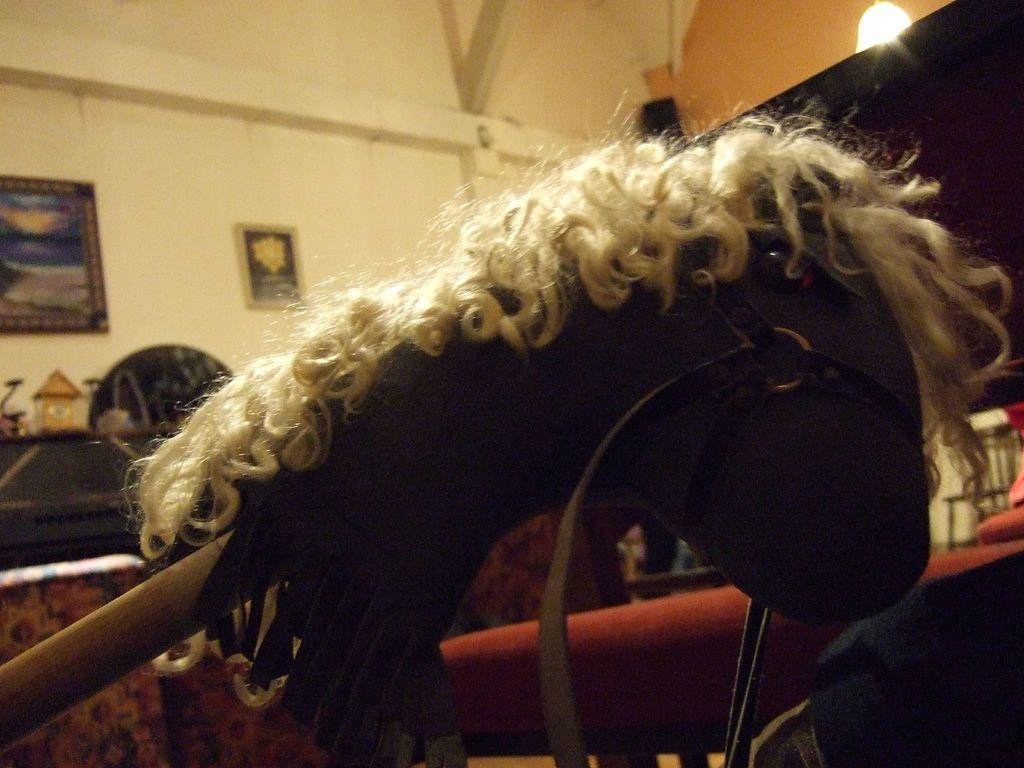What is hanging from a stick in the image? There is a doll hanging from a stick in the image. What can be seen attached to the wall in the image? There are wall hangings attached to the wall in the image. What type of light is hanging from the top in the image? There is an electric light hanging from the top in the image. Where is the drain located in the image? There is no drain present in the image. Can you see any animals from a zoo in the image? There are no animals from a zoo present in the image. 